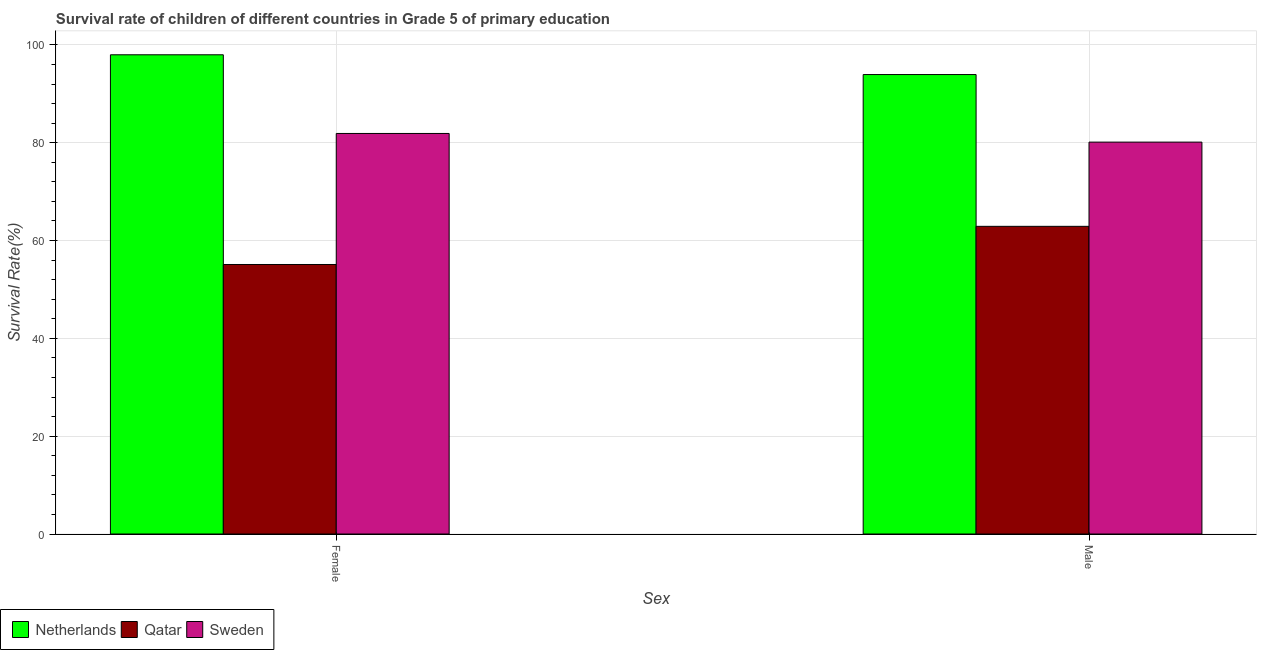How many groups of bars are there?
Keep it short and to the point. 2. Are the number of bars per tick equal to the number of legend labels?
Provide a succinct answer. Yes. Are the number of bars on each tick of the X-axis equal?
Your response must be concise. Yes. How many bars are there on the 1st tick from the left?
Provide a succinct answer. 3. How many bars are there on the 2nd tick from the right?
Ensure brevity in your answer.  3. What is the label of the 2nd group of bars from the left?
Your answer should be very brief. Male. What is the survival rate of male students in primary education in Qatar?
Keep it short and to the point. 62.9. Across all countries, what is the maximum survival rate of female students in primary education?
Provide a short and direct response. 97.98. Across all countries, what is the minimum survival rate of female students in primary education?
Keep it short and to the point. 55.1. In which country was the survival rate of female students in primary education maximum?
Provide a succinct answer. Netherlands. In which country was the survival rate of male students in primary education minimum?
Make the answer very short. Qatar. What is the total survival rate of female students in primary education in the graph?
Your response must be concise. 234.97. What is the difference between the survival rate of female students in primary education in Sweden and that in Qatar?
Ensure brevity in your answer.  26.79. What is the difference between the survival rate of male students in primary education in Sweden and the survival rate of female students in primary education in Qatar?
Keep it short and to the point. 25.02. What is the average survival rate of male students in primary education per country?
Make the answer very short. 78.99. What is the difference between the survival rate of female students in primary education and survival rate of male students in primary education in Netherlands?
Give a very brief answer. 4.04. In how many countries, is the survival rate of female students in primary education greater than 20 %?
Your answer should be very brief. 3. What is the ratio of the survival rate of female students in primary education in Sweden to that in Netherlands?
Provide a succinct answer. 0.84. Is the survival rate of male students in primary education in Netherlands less than that in Sweden?
Keep it short and to the point. No. In how many countries, is the survival rate of female students in primary education greater than the average survival rate of female students in primary education taken over all countries?
Make the answer very short. 2. What does the 2nd bar from the left in Male represents?
Offer a terse response. Qatar. How many bars are there?
Provide a succinct answer. 6. Does the graph contain grids?
Offer a very short reply. Yes. Where does the legend appear in the graph?
Keep it short and to the point. Bottom left. How are the legend labels stacked?
Your answer should be compact. Horizontal. What is the title of the graph?
Offer a very short reply. Survival rate of children of different countries in Grade 5 of primary education. What is the label or title of the X-axis?
Offer a terse response. Sex. What is the label or title of the Y-axis?
Your response must be concise. Survival Rate(%). What is the Survival Rate(%) in Netherlands in Female?
Keep it short and to the point. 97.98. What is the Survival Rate(%) in Qatar in Female?
Your response must be concise. 55.1. What is the Survival Rate(%) of Sweden in Female?
Provide a succinct answer. 81.89. What is the Survival Rate(%) of Netherlands in Male?
Your answer should be very brief. 93.93. What is the Survival Rate(%) in Qatar in Male?
Give a very brief answer. 62.9. What is the Survival Rate(%) in Sweden in Male?
Ensure brevity in your answer.  80.12. Across all Sex, what is the maximum Survival Rate(%) of Netherlands?
Give a very brief answer. 97.98. Across all Sex, what is the maximum Survival Rate(%) of Qatar?
Provide a short and direct response. 62.9. Across all Sex, what is the maximum Survival Rate(%) of Sweden?
Give a very brief answer. 81.89. Across all Sex, what is the minimum Survival Rate(%) of Netherlands?
Keep it short and to the point. 93.93. Across all Sex, what is the minimum Survival Rate(%) of Qatar?
Give a very brief answer. 55.1. Across all Sex, what is the minimum Survival Rate(%) of Sweden?
Ensure brevity in your answer.  80.12. What is the total Survival Rate(%) in Netherlands in the graph?
Your answer should be very brief. 191.91. What is the total Survival Rate(%) in Qatar in the graph?
Keep it short and to the point. 118. What is the total Survival Rate(%) of Sweden in the graph?
Give a very brief answer. 162.01. What is the difference between the Survival Rate(%) of Netherlands in Female and that in Male?
Ensure brevity in your answer.  4.04. What is the difference between the Survival Rate(%) in Qatar in Female and that in Male?
Offer a very short reply. -7.8. What is the difference between the Survival Rate(%) of Sweden in Female and that in Male?
Offer a terse response. 1.77. What is the difference between the Survival Rate(%) of Netherlands in Female and the Survival Rate(%) of Qatar in Male?
Provide a succinct answer. 35.07. What is the difference between the Survival Rate(%) of Netherlands in Female and the Survival Rate(%) of Sweden in Male?
Your answer should be very brief. 17.86. What is the difference between the Survival Rate(%) of Qatar in Female and the Survival Rate(%) of Sweden in Male?
Ensure brevity in your answer.  -25.02. What is the average Survival Rate(%) in Netherlands per Sex?
Provide a short and direct response. 95.95. What is the average Survival Rate(%) in Qatar per Sex?
Ensure brevity in your answer.  59. What is the average Survival Rate(%) of Sweden per Sex?
Ensure brevity in your answer.  81. What is the difference between the Survival Rate(%) of Netherlands and Survival Rate(%) of Qatar in Female?
Provide a succinct answer. 42.87. What is the difference between the Survival Rate(%) of Netherlands and Survival Rate(%) of Sweden in Female?
Ensure brevity in your answer.  16.09. What is the difference between the Survival Rate(%) of Qatar and Survival Rate(%) of Sweden in Female?
Your answer should be very brief. -26.79. What is the difference between the Survival Rate(%) in Netherlands and Survival Rate(%) in Qatar in Male?
Your response must be concise. 31.03. What is the difference between the Survival Rate(%) in Netherlands and Survival Rate(%) in Sweden in Male?
Offer a very short reply. 13.81. What is the difference between the Survival Rate(%) in Qatar and Survival Rate(%) in Sweden in Male?
Keep it short and to the point. -17.22. What is the ratio of the Survival Rate(%) in Netherlands in Female to that in Male?
Make the answer very short. 1.04. What is the ratio of the Survival Rate(%) in Qatar in Female to that in Male?
Ensure brevity in your answer.  0.88. What is the ratio of the Survival Rate(%) of Sweden in Female to that in Male?
Provide a short and direct response. 1.02. What is the difference between the highest and the second highest Survival Rate(%) of Netherlands?
Keep it short and to the point. 4.04. What is the difference between the highest and the second highest Survival Rate(%) in Qatar?
Ensure brevity in your answer.  7.8. What is the difference between the highest and the second highest Survival Rate(%) in Sweden?
Offer a very short reply. 1.77. What is the difference between the highest and the lowest Survival Rate(%) of Netherlands?
Provide a succinct answer. 4.04. What is the difference between the highest and the lowest Survival Rate(%) in Qatar?
Provide a succinct answer. 7.8. What is the difference between the highest and the lowest Survival Rate(%) in Sweden?
Offer a very short reply. 1.77. 